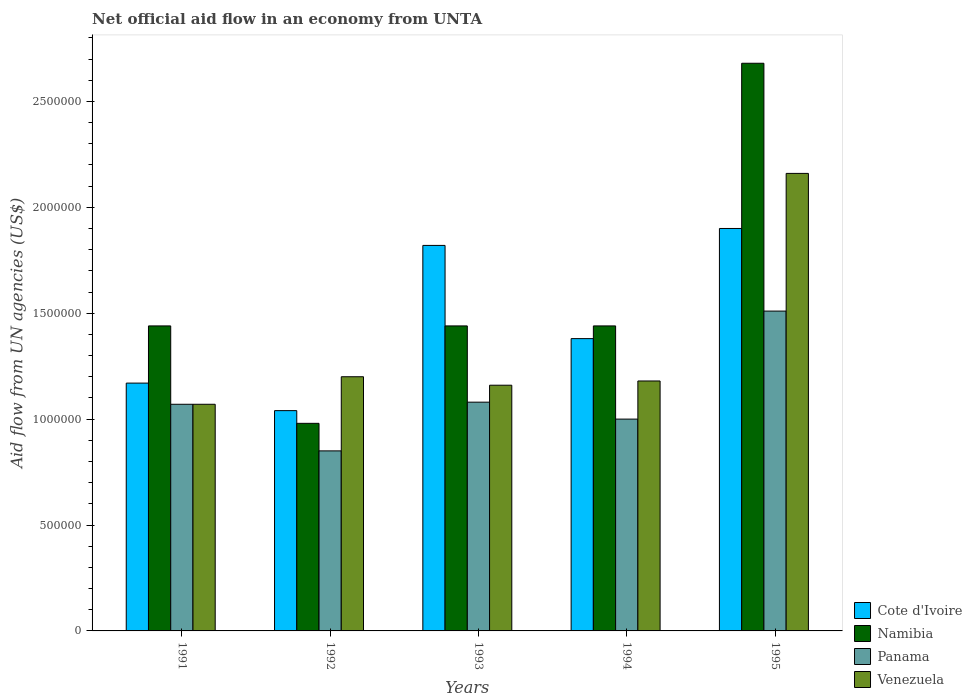How many groups of bars are there?
Offer a very short reply. 5. Are the number of bars per tick equal to the number of legend labels?
Your answer should be very brief. Yes. Are the number of bars on each tick of the X-axis equal?
Make the answer very short. Yes. How many bars are there on the 4th tick from the left?
Make the answer very short. 4. What is the net official aid flow in Venezuela in 1991?
Your answer should be very brief. 1.07e+06. Across all years, what is the maximum net official aid flow in Venezuela?
Keep it short and to the point. 2.16e+06. Across all years, what is the minimum net official aid flow in Venezuela?
Your response must be concise. 1.07e+06. In which year was the net official aid flow in Venezuela maximum?
Your answer should be compact. 1995. What is the total net official aid flow in Namibia in the graph?
Provide a short and direct response. 7.98e+06. What is the difference between the net official aid flow in Venezuela in 1991 and that in 1995?
Offer a very short reply. -1.09e+06. What is the average net official aid flow in Cote d'Ivoire per year?
Keep it short and to the point. 1.46e+06. In the year 1993, what is the difference between the net official aid flow in Panama and net official aid flow in Cote d'Ivoire?
Your answer should be compact. -7.40e+05. In how many years, is the net official aid flow in Cote d'Ivoire greater than 1400000 US$?
Provide a succinct answer. 2. What is the ratio of the net official aid flow in Namibia in 1992 to that in 1994?
Provide a succinct answer. 0.68. What is the difference between the highest and the second highest net official aid flow in Cote d'Ivoire?
Keep it short and to the point. 8.00e+04. What is the difference between the highest and the lowest net official aid flow in Namibia?
Make the answer very short. 1.70e+06. Is the sum of the net official aid flow in Cote d'Ivoire in 1991 and 1993 greater than the maximum net official aid flow in Namibia across all years?
Ensure brevity in your answer.  Yes. Is it the case that in every year, the sum of the net official aid flow in Cote d'Ivoire and net official aid flow in Namibia is greater than the sum of net official aid flow in Venezuela and net official aid flow in Panama?
Your answer should be very brief. No. What does the 2nd bar from the left in 1993 represents?
Offer a very short reply. Namibia. What does the 3rd bar from the right in 1993 represents?
Your answer should be very brief. Namibia. Is it the case that in every year, the sum of the net official aid flow in Panama and net official aid flow in Venezuela is greater than the net official aid flow in Namibia?
Offer a terse response. Yes. How many bars are there?
Provide a short and direct response. 20. Are all the bars in the graph horizontal?
Ensure brevity in your answer.  No. What is the difference between two consecutive major ticks on the Y-axis?
Your answer should be very brief. 5.00e+05. Are the values on the major ticks of Y-axis written in scientific E-notation?
Your answer should be compact. No. Where does the legend appear in the graph?
Ensure brevity in your answer.  Bottom right. How many legend labels are there?
Ensure brevity in your answer.  4. What is the title of the graph?
Offer a very short reply. Net official aid flow in an economy from UNTA. What is the label or title of the Y-axis?
Offer a terse response. Aid flow from UN agencies (US$). What is the Aid flow from UN agencies (US$) of Cote d'Ivoire in 1991?
Offer a terse response. 1.17e+06. What is the Aid flow from UN agencies (US$) of Namibia in 1991?
Your answer should be very brief. 1.44e+06. What is the Aid flow from UN agencies (US$) of Panama in 1991?
Keep it short and to the point. 1.07e+06. What is the Aid flow from UN agencies (US$) of Venezuela in 1991?
Provide a succinct answer. 1.07e+06. What is the Aid flow from UN agencies (US$) of Cote d'Ivoire in 1992?
Your answer should be very brief. 1.04e+06. What is the Aid flow from UN agencies (US$) in Namibia in 1992?
Ensure brevity in your answer.  9.80e+05. What is the Aid flow from UN agencies (US$) in Panama in 1992?
Give a very brief answer. 8.50e+05. What is the Aid flow from UN agencies (US$) in Venezuela in 1992?
Offer a very short reply. 1.20e+06. What is the Aid flow from UN agencies (US$) in Cote d'Ivoire in 1993?
Offer a very short reply. 1.82e+06. What is the Aid flow from UN agencies (US$) in Namibia in 1993?
Ensure brevity in your answer.  1.44e+06. What is the Aid flow from UN agencies (US$) of Panama in 1993?
Provide a short and direct response. 1.08e+06. What is the Aid flow from UN agencies (US$) in Venezuela in 1993?
Your answer should be very brief. 1.16e+06. What is the Aid flow from UN agencies (US$) in Cote d'Ivoire in 1994?
Give a very brief answer. 1.38e+06. What is the Aid flow from UN agencies (US$) of Namibia in 1994?
Ensure brevity in your answer.  1.44e+06. What is the Aid flow from UN agencies (US$) in Panama in 1994?
Offer a terse response. 1.00e+06. What is the Aid flow from UN agencies (US$) of Venezuela in 1994?
Make the answer very short. 1.18e+06. What is the Aid flow from UN agencies (US$) of Cote d'Ivoire in 1995?
Keep it short and to the point. 1.90e+06. What is the Aid flow from UN agencies (US$) of Namibia in 1995?
Your response must be concise. 2.68e+06. What is the Aid flow from UN agencies (US$) in Panama in 1995?
Ensure brevity in your answer.  1.51e+06. What is the Aid flow from UN agencies (US$) of Venezuela in 1995?
Make the answer very short. 2.16e+06. Across all years, what is the maximum Aid flow from UN agencies (US$) in Cote d'Ivoire?
Your response must be concise. 1.90e+06. Across all years, what is the maximum Aid flow from UN agencies (US$) in Namibia?
Your answer should be very brief. 2.68e+06. Across all years, what is the maximum Aid flow from UN agencies (US$) in Panama?
Provide a succinct answer. 1.51e+06. Across all years, what is the maximum Aid flow from UN agencies (US$) in Venezuela?
Keep it short and to the point. 2.16e+06. Across all years, what is the minimum Aid flow from UN agencies (US$) of Cote d'Ivoire?
Offer a very short reply. 1.04e+06. Across all years, what is the minimum Aid flow from UN agencies (US$) in Namibia?
Give a very brief answer. 9.80e+05. Across all years, what is the minimum Aid flow from UN agencies (US$) of Panama?
Offer a terse response. 8.50e+05. Across all years, what is the minimum Aid flow from UN agencies (US$) in Venezuela?
Offer a very short reply. 1.07e+06. What is the total Aid flow from UN agencies (US$) of Cote d'Ivoire in the graph?
Your response must be concise. 7.31e+06. What is the total Aid flow from UN agencies (US$) in Namibia in the graph?
Give a very brief answer. 7.98e+06. What is the total Aid flow from UN agencies (US$) in Panama in the graph?
Keep it short and to the point. 5.51e+06. What is the total Aid flow from UN agencies (US$) in Venezuela in the graph?
Your answer should be compact. 6.77e+06. What is the difference between the Aid flow from UN agencies (US$) in Cote d'Ivoire in 1991 and that in 1992?
Your answer should be compact. 1.30e+05. What is the difference between the Aid flow from UN agencies (US$) in Cote d'Ivoire in 1991 and that in 1993?
Give a very brief answer. -6.50e+05. What is the difference between the Aid flow from UN agencies (US$) in Namibia in 1991 and that in 1993?
Your response must be concise. 0. What is the difference between the Aid flow from UN agencies (US$) of Panama in 1991 and that in 1993?
Your answer should be compact. -10000. What is the difference between the Aid flow from UN agencies (US$) of Panama in 1991 and that in 1994?
Ensure brevity in your answer.  7.00e+04. What is the difference between the Aid flow from UN agencies (US$) in Venezuela in 1991 and that in 1994?
Your answer should be compact. -1.10e+05. What is the difference between the Aid flow from UN agencies (US$) in Cote d'Ivoire in 1991 and that in 1995?
Provide a short and direct response. -7.30e+05. What is the difference between the Aid flow from UN agencies (US$) in Namibia in 1991 and that in 1995?
Offer a very short reply. -1.24e+06. What is the difference between the Aid flow from UN agencies (US$) of Panama in 1991 and that in 1995?
Offer a very short reply. -4.40e+05. What is the difference between the Aid flow from UN agencies (US$) of Venezuela in 1991 and that in 1995?
Provide a short and direct response. -1.09e+06. What is the difference between the Aid flow from UN agencies (US$) in Cote d'Ivoire in 1992 and that in 1993?
Your response must be concise. -7.80e+05. What is the difference between the Aid flow from UN agencies (US$) in Namibia in 1992 and that in 1993?
Keep it short and to the point. -4.60e+05. What is the difference between the Aid flow from UN agencies (US$) in Panama in 1992 and that in 1993?
Your response must be concise. -2.30e+05. What is the difference between the Aid flow from UN agencies (US$) of Venezuela in 1992 and that in 1993?
Offer a terse response. 4.00e+04. What is the difference between the Aid flow from UN agencies (US$) of Cote d'Ivoire in 1992 and that in 1994?
Your answer should be very brief. -3.40e+05. What is the difference between the Aid flow from UN agencies (US$) in Namibia in 1992 and that in 1994?
Give a very brief answer. -4.60e+05. What is the difference between the Aid flow from UN agencies (US$) in Cote d'Ivoire in 1992 and that in 1995?
Keep it short and to the point. -8.60e+05. What is the difference between the Aid flow from UN agencies (US$) of Namibia in 1992 and that in 1995?
Your response must be concise. -1.70e+06. What is the difference between the Aid flow from UN agencies (US$) of Panama in 1992 and that in 1995?
Provide a short and direct response. -6.60e+05. What is the difference between the Aid flow from UN agencies (US$) of Venezuela in 1992 and that in 1995?
Ensure brevity in your answer.  -9.60e+05. What is the difference between the Aid flow from UN agencies (US$) in Cote d'Ivoire in 1993 and that in 1994?
Offer a very short reply. 4.40e+05. What is the difference between the Aid flow from UN agencies (US$) in Panama in 1993 and that in 1994?
Your response must be concise. 8.00e+04. What is the difference between the Aid flow from UN agencies (US$) of Namibia in 1993 and that in 1995?
Ensure brevity in your answer.  -1.24e+06. What is the difference between the Aid flow from UN agencies (US$) in Panama in 1993 and that in 1995?
Keep it short and to the point. -4.30e+05. What is the difference between the Aid flow from UN agencies (US$) in Cote d'Ivoire in 1994 and that in 1995?
Your answer should be compact. -5.20e+05. What is the difference between the Aid flow from UN agencies (US$) of Namibia in 1994 and that in 1995?
Your answer should be compact. -1.24e+06. What is the difference between the Aid flow from UN agencies (US$) of Panama in 1994 and that in 1995?
Your response must be concise. -5.10e+05. What is the difference between the Aid flow from UN agencies (US$) of Venezuela in 1994 and that in 1995?
Provide a short and direct response. -9.80e+05. What is the difference between the Aid flow from UN agencies (US$) of Cote d'Ivoire in 1991 and the Aid flow from UN agencies (US$) of Namibia in 1992?
Your answer should be very brief. 1.90e+05. What is the difference between the Aid flow from UN agencies (US$) of Cote d'Ivoire in 1991 and the Aid flow from UN agencies (US$) of Venezuela in 1992?
Keep it short and to the point. -3.00e+04. What is the difference between the Aid flow from UN agencies (US$) in Namibia in 1991 and the Aid flow from UN agencies (US$) in Panama in 1992?
Your response must be concise. 5.90e+05. What is the difference between the Aid flow from UN agencies (US$) in Namibia in 1991 and the Aid flow from UN agencies (US$) in Venezuela in 1992?
Provide a short and direct response. 2.40e+05. What is the difference between the Aid flow from UN agencies (US$) of Panama in 1991 and the Aid flow from UN agencies (US$) of Venezuela in 1992?
Your answer should be very brief. -1.30e+05. What is the difference between the Aid flow from UN agencies (US$) in Cote d'Ivoire in 1991 and the Aid flow from UN agencies (US$) in Namibia in 1993?
Your answer should be very brief. -2.70e+05. What is the difference between the Aid flow from UN agencies (US$) of Cote d'Ivoire in 1991 and the Aid flow from UN agencies (US$) of Venezuela in 1993?
Ensure brevity in your answer.  10000. What is the difference between the Aid flow from UN agencies (US$) of Panama in 1991 and the Aid flow from UN agencies (US$) of Venezuela in 1993?
Your answer should be compact. -9.00e+04. What is the difference between the Aid flow from UN agencies (US$) of Cote d'Ivoire in 1991 and the Aid flow from UN agencies (US$) of Namibia in 1994?
Your answer should be compact. -2.70e+05. What is the difference between the Aid flow from UN agencies (US$) of Cote d'Ivoire in 1991 and the Aid flow from UN agencies (US$) of Venezuela in 1994?
Your answer should be compact. -10000. What is the difference between the Aid flow from UN agencies (US$) of Namibia in 1991 and the Aid flow from UN agencies (US$) of Panama in 1994?
Ensure brevity in your answer.  4.40e+05. What is the difference between the Aid flow from UN agencies (US$) in Cote d'Ivoire in 1991 and the Aid flow from UN agencies (US$) in Namibia in 1995?
Your response must be concise. -1.51e+06. What is the difference between the Aid flow from UN agencies (US$) in Cote d'Ivoire in 1991 and the Aid flow from UN agencies (US$) in Panama in 1995?
Your answer should be very brief. -3.40e+05. What is the difference between the Aid flow from UN agencies (US$) in Cote d'Ivoire in 1991 and the Aid flow from UN agencies (US$) in Venezuela in 1995?
Your answer should be compact. -9.90e+05. What is the difference between the Aid flow from UN agencies (US$) of Namibia in 1991 and the Aid flow from UN agencies (US$) of Venezuela in 1995?
Your answer should be very brief. -7.20e+05. What is the difference between the Aid flow from UN agencies (US$) in Panama in 1991 and the Aid flow from UN agencies (US$) in Venezuela in 1995?
Offer a very short reply. -1.09e+06. What is the difference between the Aid flow from UN agencies (US$) of Cote d'Ivoire in 1992 and the Aid flow from UN agencies (US$) of Namibia in 1993?
Keep it short and to the point. -4.00e+05. What is the difference between the Aid flow from UN agencies (US$) of Cote d'Ivoire in 1992 and the Aid flow from UN agencies (US$) of Panama in 1993?
Provide a succinct answer. -4.00e+04. What is the difference between the Aid flow from UN agencies (US$) in Namibia in 1992 and the Aid flow from UN agencies (US$) in Venezuela in 1993?
Your response must be concise. -1.80e+05. What is the difference between the Aid flow from UN agencies (US$) of Panama in 1992 and the Aid flow from UN agencies (US$) of Venezuela in 1993?
Give a very brief answer. -3.10e+05. What is the difference between the Aid flow from UN agencies (US$) in Cote d'Ivoire in 1992 and the Aid flow from UN agencies (US$) in Namibia in 1994?
Offer a very short reply. -4.00e+05. What is the difference between the Aid flow from UN agencies (US$) in Cote d'Ivoire in 1992 and the Aid flow from UN agencies (US$) in Panama in 1994?
Your answer should be compact. 4.00e+04. What is the difference between the Aid flow from UN agencies (US$) of Cote d'Ivoire in 1992 and the Aid flow from UN agencies (US$) of Venezuela in 1994?
Give a very brief answer. -1.40e+05. What is the difference between the Aid flow from UN agencies (US$) of Namibia in 1992 and the Aid flow from UN agencies (US$) of Panama in 1994?
Provide a short and direct response. -2.00e+04. What is the difference between the Aid flow from UN agencies (US$) in Namibia in 1992 and the Aid flow from UN agencies (US$) in Venezuela in 1994?
Give a very brief answer. -2.00e+05. What is the difference between the Aid flow from UN agencies (US$) in Panama in 1992 and the Aid flow from UN agencies (US$) in Venezuela in 1994?
Your answer should be compact. -3.30e+05. What is the difference between the Aid flow from UN agencies (US$) in Cote d'Ivoire in 1992 and the Aid flow from UN agencies (US$) in Namibia in 1995?
Offer a very short reply. -1.64e+06. What is the difference between the Aid flow from UN agencies (US$) in Cote d'Ivoire in 1992 and the Aid flow from UN agencies (US$) in Panama in 1995?
Your response must be concise. -4.70e+05. What is the difference between the Aid flow from UN agencies (US$) of Cote d'Ivoire in 1992 and the Aid flow from UN agencies (US$) of Venezuela in 1995?
Ensure brevity in your answer.  -1.12e+06. What is the difference between the Aid flow from UN agencies (US$) in Namibia in 1992 and the Aid flow from UN agencies (US$) in Panama in 1995?
Your response must be concise. -5.30e+05. What is the difference between the Aid flow from UN agencies (US$) of Namibia in 1992 and the Aid flow from UN agencies (US$) of Venezuela in 1995?
Provide a succinct answer. -1.18e+06. What is the difference between the Aid flow from UN agencies (US$) of Panama in 1992 and the Aid flow from UN agencies (US$) of Venezuela in 1995?
Your answer should be very brief. -1.31e+06. What is the difference between the Aid flow from UN agencies (US$) of Cote d'Ivoire in 1993 and the Aid flow from UN agencies (US$) of Panama in 1994?
Provide a succinct answer. 8.20e+05. What is the difference between the Aid flow from UN agencies (US$) in Cote d'Ivoire in 1993 and the Aid flow from UN agencies (US$) in Venezuela in 1994?
Your response must be concise. 6.40e+05. What is the difference between the Aid flow from UN agencies (US$) in Panama in 1993 and the Aid flow from UN agencies (US$) in Venezuela in 1994?
Provide a short and direct response. -1.00e+05. What is the difference between the Aid flow from UN agencies (US$) in Cote d'Ivoire in 1993 and the Aid flow from UN agencies (US$) in Namibia in 1995?
Make the answer very short. -8.60e+05. What is the difference between the Aid flow from UN agencies (US$) of Cote d'Ivoire in 1993 and the Aid flow from UN agencies (US$) of Venezuela in 1995?
Ensure brevity in your answer.  -3.40e+05. What is the difference between the Aid flow from UN agencies (US$) in Namibia in 1993 and the Aid flow from UN agencies (US$) in Panama in 1995?
Keep it short and to the point. -7.00e+04. What is the difference between the Aid flow from UN agencies (US$) of Namibia in 1993 and the Aid flow from UN agencies (US$) of Venezuela in 1995?
Give a very brief answer. -7.20e+05. What is the difference between the Aid flow from UN agencies (US$) of Panama in 1993 and the Aid flow from UN agencies (US$) of Venezuela in 1995?
Make the answer very short. -1.08e+06. What is the difference between the Aid flow from UN agencies (US$) in Cote d'Ivoire in 1994 and the Aid flow from UN agencies (US$) in Namibia in 1995?
Your response must be concise. -1.30e+06. What is the difference between the Aid flow from UN agencies (US$) of Cote d'Ivoire in 1994 and the Aid flow from UN agencies (US$) of Venezuela in 1995?
Ensure brevity in your answer.  -7.80e+05. What is the difference between the Aid flow from UN agencies (US$) of Namibia in 1994 and the Aid flow from UN agencies (US$) of Panama in 1995?
Provide a succinct answer. -7.00e+04. What is the difference between the Aid flow from UN agencies (US$) in Namibia in 1994 and the Aid flow from UN agencies (US$) in Venezuela in 1995?
Your answer should be very brief. -7.20e+05. What is the difference between the Aid flow from UN agencies (US$) of Panama in 1994 and the Aid flow from UN agencies (US$) of Venezuela in 1995?
Provide a short and direct response. -1.16e+06. What is the average Aid flow from UN agencies (US$) in Cote d'Ivoire per year?
Your answer should be compact. 1.46e+06. What is the average Aid flow from UN agencies (US$) in Namibia per year?
Provide a short and direct response. 1.60e+06. What is the average Aid flow from UN agencies (US$) in Panama per year?
Keep it short and to the point. 1.10e+06. What is the average Aid flow from UN agencies (US$) in Venezuela per year?
Make the answer very short. 1.35e+06. In the year 1991, what is the difference between the Aid flow from UN agencies (US$) in Cote d'Ivoire and Aid flow from UN agencies (US$) in Namibia?
Give a very brief answer. -2.70e+05. In the year 1991, what is the difference between the Aid flow from UN agencies (US$) of Cote d'Ivoire and Aid flow from UN agencies (US$) of Panama?
Offer a terse response. 1.00e+05. In the year 1991, what is the difference between the Aid flow from UN agencies (US$) in Panama and Aid flow from UN agencies (US$) in Venezuela?
Your answer should be compact. 0. In the year 1992, what is the difference between the Aid flow from UN agencies (US$) of Cote d'Ivoire and Aid flow from UN agencies (US$) of Namibia?
Ensure brevity in your answer.  6.00e+04. In the year 1992, what is the difference between the Aid flow from UN agencies (US$) in Cote d'Ivoire and Aid flow from UN agencies (US$) in Panama?
Offer a terse response. 1.90e+05. In the year 1992, what is the difference between the Aid flow from UN agencies (US$) of Cote d'Ivoire and Aid flow from UN agencies (US$) of Venezuela?
Make the answer very short. -1.60e+05. In the year 1992, what is the difference between the Aid flow from UN agencies (US$) in Panama and Aid flow from UN agencies (US$) in Venezuela?
Your answer should be compact. -3.50e+05. In the year 1993, what is the difference between the Aid flow from UN agencies (US$) in Cote d'Ivoire and Aid flow from UN agencies (US$) in Panama?
Give a very brief answer. 7.40e+05. In the year 1993, what is the difference between the Aid flow from UN agencies (US$) of Namibia and Aid flow from UN agencies (US$) of Panama?
Your response must be concise. 3.60e+05. In the year 1994, what is the difference between the Aid flow from UN agencies (US$) of Namibia and Aid flow from UN agencies (US$) of Venezuela?
Make the answer very short. 2.60e+05. In the year 1995, what is the difference between the Aid flow from UN agencies (US$) in Cote d'Ivoire and Aid flow from UN agencies (US$) in Namibia?
Make the answer very short. -7.80e+05. In the year 1995, what is the difference between the Aid flow from UN agencies (US$) in Cote d'Ivoire and Aid flow from UN agencies (US$) in Venezuela?
Your answer should be very brief. -2.60e+05. In the year 1995, what is the difference between the Aid flow from UN agencies (US$) of Namibia and Aid flow from UN agencies (US$) of Panama?
Offer a very short reply. 1.17e+06. In the year 1995, what is the difference between the Aid flow from UN agencies (US$) in Namibia and Aid flow from UN agencies (US$) in Venezuela?
Your response must be concise. 5.20e+05. In the year 1995, what is the difference between the Aid flow from UN agencies (US$) of Panama and Aid flow from UN agencies (US$) of Venezuela?
Your answer should be very brief. -6.50e+05. What is the ratio of the Aid flow from UN agencies (US$) of Cote d'Ivoire in 1991 to that in 1992?
Provide a succinct answer. 1.12. What is the ratio of the Aid flow from UN agencies (US$) in Namibia in 1991 to that in 1992?
Offer a terse response. 1.47. What is the ratio of the Aid flow from UN agencies (US$) of Panama in 1991 to that in 1992?
Offer a very short reply. 1.26. What is the ratio of the Aid flow from UN agencies (US$) in Venezuela in 1991 to that in 1992?
Give a very brief answer. 0.89. What is the ratio of the Aid flow from UN agencies (US$) in Cote d'Ivoire in 1991 to that in 1993?
Give a very brief answer. 0.64. What is the ratio of the Aid flow from UN agencies (US$) of Namibia in 1991 to that in 1993?
Offer a very short reply. 1. What is the ratio of the Aid flow from UN agencies (US$) of Panama in 1991 to that in 1993?
Your response must be concise. 0.99. What is the ratio of the Aid flow from UN agencies (US$) in Venezuela in 1991 to that in 1993?
Provide a succinct answer. 0.92. What is the ratio of the Aid flow from UN agencies (US$) of Cote d'Ivoire in 1991 to that in 1994?
Keep it short and to the point. 0.85. What is the ratio of the Aid flow from UN agencies (US$) in Panama in 1991 to that in 1994?
Your response must be concise. 1.07. What is the ratio of the Aid flow from UN agencies (US$) of Venezuela in 1991 to that in 1994?
Provide a succinct answer. 0.91. What is the ratio of the Aid flow from UN agencies (US$) of Cote d'Ivoire in 1991 to that in 1995?
Your answer should be compact. 0.62. What is the ratio of the Aid flow from UN agencies (US$) in Namibia in 1991 to that in 1995?
Keep it short and to the point. 0.54. What is the ratio of the Aid flow from UN agencies (US$) in Panama in 1991 to that in 1995?
Provide a succinct answer. 0.71. What is the ratio of the Aid flow from UN agencies (US$) of Venezuela in 1991 to that in 1995?
Your response must be concise. 0.5. What is the ratio of the Aid flow from UN agencies (US$) in Cote d'Ivoire in 1992 to that in 1993?
Your answer should be very brief. 0.57. What is the ratio of the Aid flow from UN agencies (US$) in Namibia in 1992 to that in 1993?
Your answer should be very brief. 0.68. What is the ratio of the Aid flow from UN agencies (US$) in Panama in 1992 to that in 1993?
Ensure brevity in your answer.  0.79. What is the ratio of the Aid flow from UN agencies (US$) of Venezuela in 1992 to that in 1993?
Ensure brevity in your answer.  1.03. What is the ratio of the Aid flow from UN agencies (US$) of Cote d'Ivoire in 1992 to that in 1994?
Offer a terse response. 0.75. What is the ratio of the Aid flow from UN agencies (US$) of Namibia in 1992 to that in 1994?
Offer a very short reply. 0.68. What is the ratio of the Aid flow from UN agencies (US$) of Venezuela in 1992 to that in 1994?
Ensure brevity in your answer.  1.02. What is the ratio of the Aid flow from UN agencies (US$) in Cote d'Ivoire in 1992 to that in 1995?
Your answer should be compact. 0.55. What is the ratio of the Aid flow from UN agencies (US$) of Namibia in 1992 to that in 1995?
Keep it short and to the point. 0.37. What is the ratio of the Aid flow from UN agencies (US$) of Panama in 1992 to that in 1995?
Your answer should be very brief. 0.56. What is the ratio of the Aid flow from UN agencies (US$) of Venezuela in 1992 to that in 1995?
Your answer should be compact. 0.56. What is the ratio of the Aid flow from UN agencies (US$) in Cote d'Ivoire in 1993 to that in 1994?
Give a very brief answer. 1.32. What is the ratio of the Aid flow from UN agencies (US$) of Namibia in 1993 to that in 1994?
Your response must be concise. 1. What is the ratio of the Aid flow from UN agencies (US$) of Panama in 1993 to that in 1994?
Make the answer very short. 1.08. What is the ratio of the Aid flow from UN agencies (US$) in Venezuela in 1993 to that in 1994?
Keep it short and to the point. 0.98. What is the ratio of the Aid flow from UN agencies (US$) of Cote d'Ivoire in 1993 to that in 1995?
Keep it short and to the point. 0.96. What is the ratio of the Aid flow from UN agencies (US$) in Namibia in 1993 to that in 1995?
Keep it short and to the point. 0.54. What is the ratio of the Aid flow from UN agencies (US$) of Panama in 1993 to that in 1995?
Offer a terse response. 0.72. What is the ratio of the Aid flow from UN agencies (US$) in Venezuela in 1993 to that in 1995?
Offer a very short reply. 0.54. What is the ratio of the Aid flow from UN agencies (US$) of Cote d'Ivoire in 1994 to that in 1995?
Your response must be concise. 0.73. What is the ratio of the Aid flow from UN agencies (US$) of Namibia in 1994 to that in 1995?
Offer a terse response. 0.54. What is the ratio of the Aid flow from UN agencies (US$) in Panama in 1994 to that in 1995?
Provide a succinct answer. 0.66. What is the ratio of the Aid flow from UN agencies (US$) of Venezuela in 1994 to that in 1995?
Make the answer very short. 0.55. What is the difference between the highest and the second highest Aid flow from UN agencies (US$) in Namibia?
Offer a very short reply. 1.24e+06. What is the difference between the highest and the second highest Aid flow from UN agencies (US$) of Venezuela?
Keep it short and to the point. 9.60e+05. What is the difference between the highest and the lowest Aid flow from UN agencies (US$) in Cote d'Ivoire?
Ensure brevity in your answer.  8.60e+05. What is the difference between the highest and the lowest Aid flow from UN agencies (US$) in Namibia?
Offer a very short reply. 1.70e+06. What is the difference between the highest and the lowest Aid flow from UN agencies (US$) of Venezuela?
Your answer should be compact. 1.09e+06. 